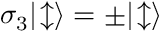Convert formula to latex. <formula><loc_0><loc_0><loc_500><loc_500>\sigma _ { 3 } | \, \updownarrow \rangle = \pm | \, \updownarrow \rangle</formula> 